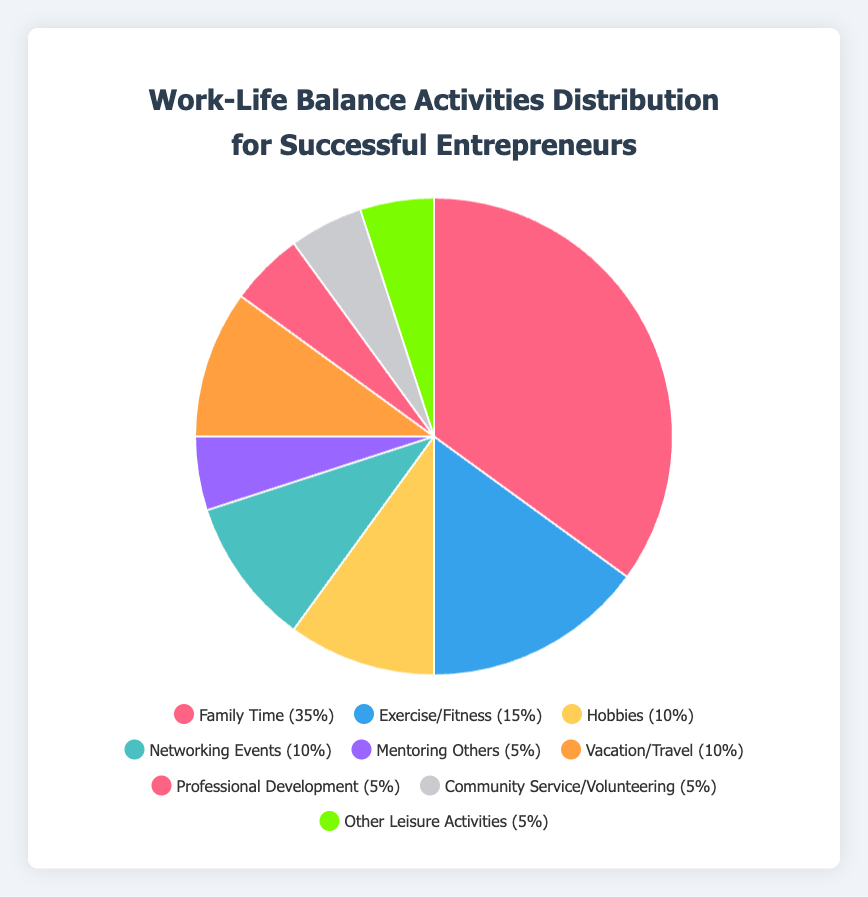What activity has the highest percentage in the pie chart? The activity with the highest percentage is the one with the largest slice in the pie chart. In the chart, this activity is "Family Time" with 35%.
Answer: Family Time Which activities share the same percentage of representation in the chart? Examine the chart for slices that are equal in size. The activities "Professional Development," "Community Service/Volunteering," and "Other Leisure Activities" each have 5%.
Answer: Professional Development, Community Service/Volunteering, Other Leisure Activities What is the combined percentage of "Networking Events" and "Vacation/Travel"? The percentages for "Networking Events" and "Vacation/Travel" are 10% each. Adding these together gives 10% + 10% = 20%.
Answer: 20% How much more emphasis is placed on "Family Time" compared to "Exercise/Fitness" based on their percentages? "Family Time" is 35% and "Exercise/Fitness" is 15%. The difference is 35% - 15% = 20%.
Answer: 20% What portion of the pie chart is occupied by non-family-related activities? Sum the percentages of all activities except "Family Time": 15% (Exercise/Fitness) + 10% (Hobbies) + 10% (Networking Events) + 5% (Mentoring Others) + 10% (Vacation/Travel) + 5% (Professional Development) + 5% (Community Service/Volunteering) + 5% (Other Leisure Activities) = 65%.
Answer: 65% How does the percentage of time allocated to "Networking Events" compare to that of "Hobbies"? The chart shows "Networking Events" at 10% and "Hobbies" also at 10%. These two activities have equal representation.
Answer: Equal Which activity has the smallest representation when compared individually to all other activities? The smallest percentage in the chart is 5%, and multiple activities share this value: "Mentoring Others", "Professional Development", "Community Service/Volunteering", and "Other Leisure Activities".
Answer: Mentoring Others, Professional Development, Community Service/Volunteering, Other Leisure Activities What is the average percentage of the activities excluding "Family Time"? Excluding "Family Time" (35%), sum the remaining percentages: 15% + 10% + 10% + 5% + 10% + 5% + 5% + 5% = 65%. There are 8 activities excluding "Family Time", so the average is 65% / 8 = 8.125%.
Answer: 8.125% Which activity group ("Exercise/Fitness," "Hobbies," "Networking Events," "Mentoring Others," "Vacation/Travel," "Professional Development," "Community Service/Volunteering," "Other Leisure Activities") represents the same percentage as the sum of "Exercise/Fitness" and "Mentoring Others"? The sum of "Exercise/Fitness" (15%) and "Mentoring Others" (5%) is 15% + 5% = 20%. None of the individual activities match exactly with this sum; hence there is no single activity representing 20%.
Answer: None 